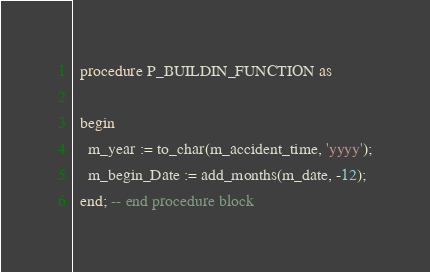<code> <loc_0><loc_0><loc_500><loc_500><_SQL_>
  procedure P_BUILDIN_FUNCTION as

  begin
    m_year := to_char(m_accident_time, 'yyyy');
    m_begin_Date := add_months(m_date, -12);
  end; -- end procedure block
</code> 